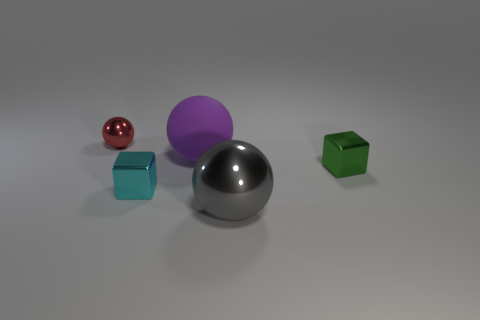Add 2 blue metal spheres. How many objects exist? 7 Subtract all blocks. How many objects are left? 3 Add 2 purple cylinders. How many purple cylinders exist? 2 Subtract 0 cyan cylinders. How many objects are left? 5 Subtract all large blue matte cylinders. Subtract all large purple matte things. How many objects are left? 4 Add 1 small cyan metal objects. How many small cyan metal objects are left? 2 